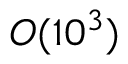<formula> <loc_0><loc_0><loc_500><loc_500>O ( 1 0 ^ { 3 } )</formula> 